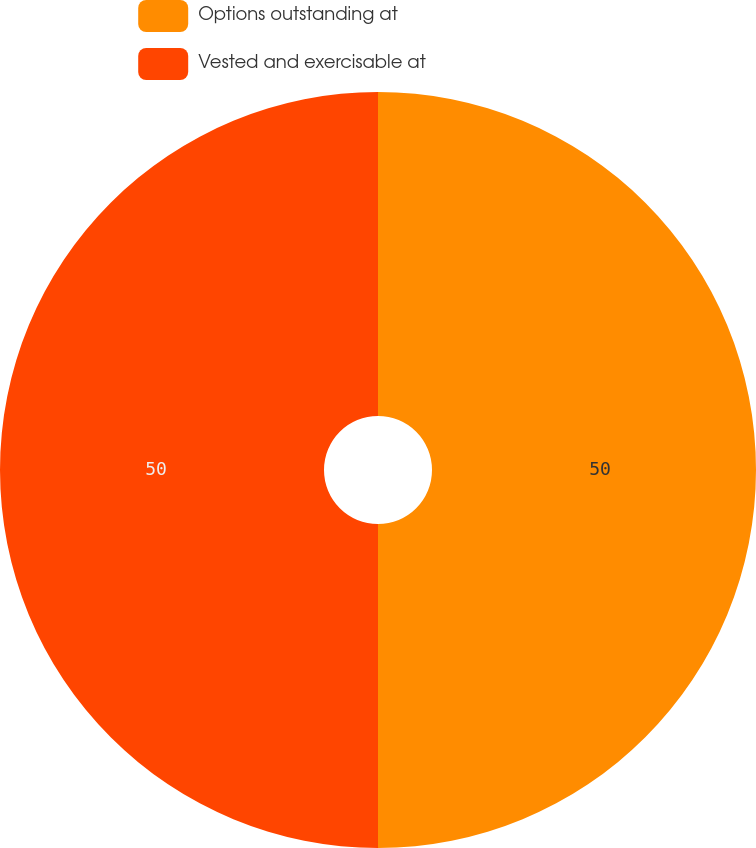Convert chart to OTSL. <chart><loc_0><loc_0><loc_500><loc_500><pie_chart><fcel>Options outstanding at<fcel>Vested and exercisable at<nl><fcel>50.0%<fcel>50.0%<nl></chart> 